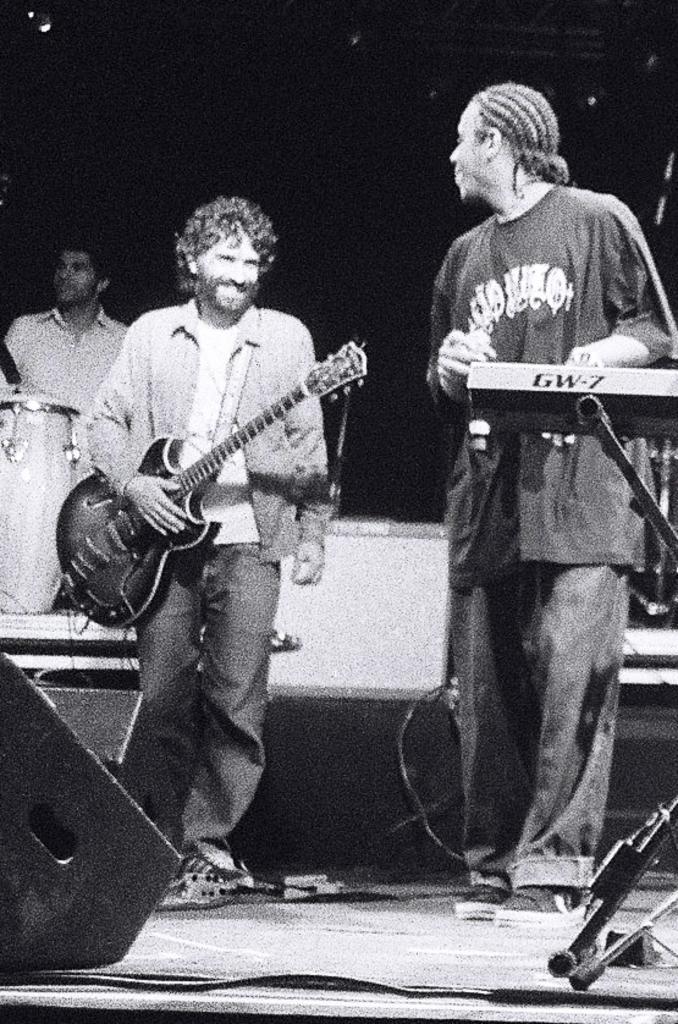In one or two sentences, can you explain what this image depicts? In this image there are people standing. In the center there is a man standing and holding a guitar in his hand, next to him there is another man who is playing a piano. In the background there is a drum and a person. At the left there is a speaker. 